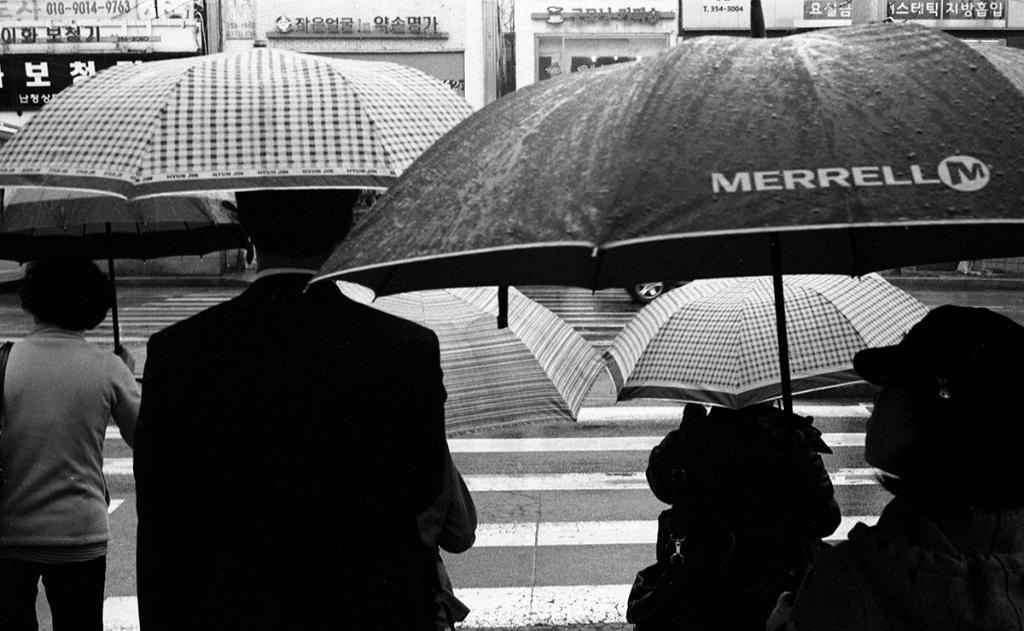What are the people near the road doing? The people near the road are standing. What are the people holding while standing near the road? The people are holding umbrellas. What can be seen across the road from the people? There are buildings with shops visible opposite to the people. Can you see a kitty playing with a twig on the road in the image? There is no kitty or twig present on the road in the image. 